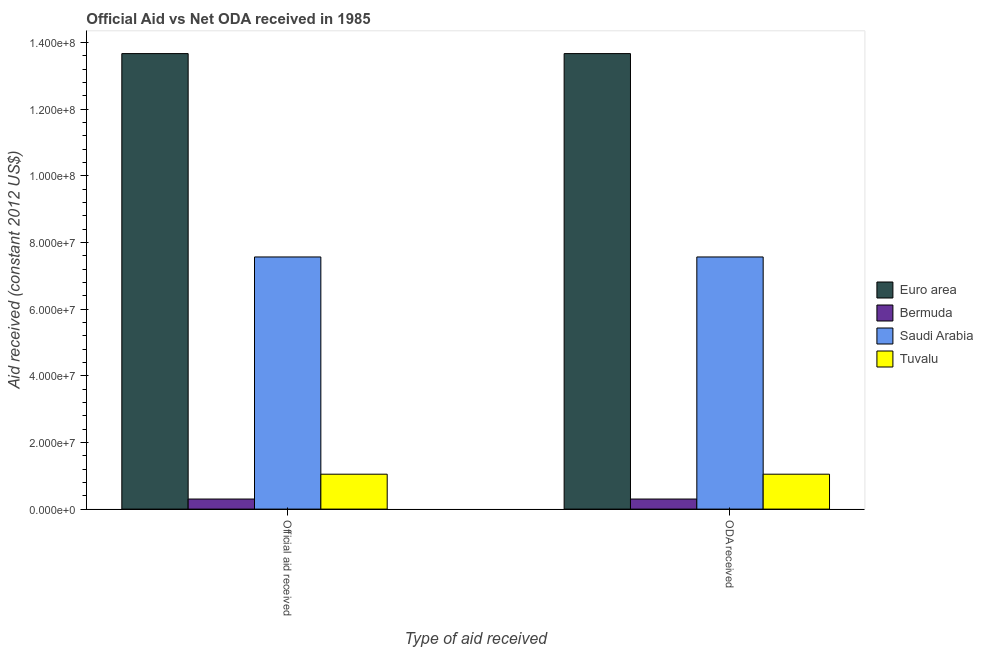How many different coloured bars are there?
Give a very brief answer. 4. How many bars are there on the 2nd tick from the left?
Offer a terse response. 4. What is the label of the 2nd group of bars from the left?
Provide a short and direct response. ODA received. What is the official aid received in Saudi Arabia?
Give a very brief answer. 7.56e+07. Across all countries, what is the maximum official aid received?
Offer a very short reply. 1.37e+08. Across all countries, what is the minimum oda received?
Offer a terse response. 3.02e+06. In which country was the official aid received maximum?
Provide a short and direct response. Euro area. In which country was the oda received minimum?
Make the answer very short. Bermuda. What is the total official aid received in the graph?
Keep it short and to the point. 2.26e+08. What is the difference between the official aid received in Saudi Arabia and that in Euro area?
Your answer should be very brief. -6.10e+07. What is the difference between the official aid received in Euro area and the oda received in Saudi Arabia?
Your answer should be very brief. 6.10e+07. What is the average oda received per country?
Your answer should be very brief. 5.64e+07. In how many countries, is the official aid received greater than 104000000 US$?
Offer a very short reply. 1. What is the ratio of the official aid received in Tuvalu to that in Euro area?
Provide a succinct answer. 0.08. Is the official aid received in Saudi Arabia less than that in Euro area?
Make the answer very short. Yes. In how many countries, is the oda received greater than the average oda received taken over all countries?
Provide a short and direct response. 2. What does the 2nd bar from the left in ODA received represents?
Ensure brevity in your answer.  Bermuda. What does the 3rd bar from the right in ODA received represents?
Provide a succinct answer. Bermuda. Are all the bars in the graph horizontal?
Your answer should be very brief. No. How many countries are there in the graph?
Give a very brief answer. 4. Are the values on the major ticks of Y-axis written in scientific E-notation?
Your answer should be compact. Yes. How many legend labels are there?
Provide a succinct answer. 4. How are the legend labels stacked?
Give a very brief answer. Vertical. What is the title of the graph?
Your answer should be compact. Official Aid vs Net ODA received in 1985 . Does "Seychelles" appear as one of the legend labels in the graph?
Ensure brevity in your answer.  No. What is the label or title of the X-axis?
Keep it short and to the point. Type of aid received. What is the label or title of the Y-axis?
Offer a terse response. Aid received (constant 2012 US$). What is the Aid received (constant 2012 US$) of Euro area in Official aid received?
Provide a short and direct response. 1.37e+08. What is the Aid received (constant 2012 US$) in Bermuda in Official aid received?
Give a very brief answer. 3.02e+06. What is the Aid received (constant 2012 US$) in Saudi Arabia in Official aid received?
Make the answer very short. 7.56e+07. What is the Aid received (constant 2012 US$) in Tuvalu in Official aid received?
Make the answer very short. 1.05e+07. What is the Aid received (constant 2012 US$) of Euro area in ODA received?
Make the answer very short. 1.37e+08. What is the Aid received (constant 2012 US$) of Bermuda in ODA received?
Your response must be concise. 3.02e+06. What is the Aid received (constant 2012 US$) of Saudi Arabia in ODA received?
Keep it short and to the point. 7.56e+07. What is the Aid received (constant 2012 US$) of Tuvalu in ODA received?
Keep it short and to the point. 1.05e+07. Across all Type of aid received, what is the maximum Aid received (constant 2012 US$) of Euro area?
Give a very brief answer. 1.37e+08. Across all Type of aid received, what is the maximum Aid received (constant 2012 US$) in Bermuda?
Your answer should be compact. 3.02e+06. Across all Type of aid received, what is the maximum Aid received (constant 2012 US$) in Saudi Arabia?
Give a very brief answer. 7.56e+07. Across all Type of aid received, what is the maximum Aid received (constant 2012 US$) in Tuvalu?
Offer a very short reply. 1.05e+07. Across all Type of aid received, what is the minimum Aid received (constant 2012 US$) of Euro area?
Your answer should be very brief. 1.37e+08. Across all Type of aid received, what is the minimum Aid received (constant 2012 US$) in Bermuda?
Provide a succinct answer. 3.02e+06. Across all Type of aid received, what is the minimum Aid received (constant 2012 US$) in Saudi Arabia?
Make the answer very short. 7.56e+07. Across all Type of aid received, what is the minimum Aid received (constant 2012 US$) of Tuvalu?
Ensure brevity in your answer.  1.05e+07. What is the total Aid received (constant 2012 US$) of Euro area in the graph?
Your answer should be compact. 2.73e+08. What is the total Aid received (constant 2012 US$) in Bermuda in the graph?
Make the answer very short. 6.04e+06. What is the total Aid received (constant 2012 US$) of Saudi Arabia in the graph?
Provide a succinct answer. 1.51e+08. What is the total Aid received (constant 2012 US$) of Tuvalu in the graph?
Keep it short and to the point. 2.09e+07. What is the difference between the Aid received (constant 2012 US$) of Euro area in Official aid received and that in ODA received?
Your answer should be compact. 0. What is the difference between the Aid received (constant 2012 US$) in Bermuda in Official aid received and that in ODA received?
Provide a short and direct response. 0. What is the difference between the Aid received (constant 2012 US$) of Tuvalu in Official aid received and that in ODA received?
Provide a succinct answer. 0. What is the difference between the Aid received (constant 2012 US$) of Euro area in Official aid received and the Aid received (constant 2012 US$) of Bermuda in ODA received?
Provide a short and direct response. 1.34e+08. What is the difference between the Aid received (constant 2012 US$) in Euro area in Official aid received and the Aid received (constant 2012 US$) in Saudi Arabia in ODA received?
Keep it short and to the point. 6.10e+07. What is the difference between the Aid received (constant 2012 US$) of Euro area in Official aid received and the Aid received (constant 2012 US$) of Tuvalu in ODA received?
Offer a very short reply. 1.26e+08. What is the difference between the Aid received (constant 2012 US$) of Bermuda in Official aid received and the Aid received (constant 2012 US$) of Saudi Arabia in ODA received?
Provide a succinct answer. -7.26e+07. What is the difference between the Aid received (constant 2012 US$) in Bermuda in Official aid received and the Aid received (constant 2012 US$) in Tuvalu in ODA received?
Give a very brief answer. -7.45e+06. What is the difference between the Aid received (constant 2012 US$) in Saudi Arabia in Official aid received and the Aid received (constant 2012 US$) in Tuvalu in ODA received?
Your answer should be very brief. 6.52e+07. What is the average Aid received (constant 2012 US$) in Euro area per Type of aid received?
Offer a very short reply. 1.37e+08. What is the average Aid received (constant 2012 US$) of Bermuda per Type of aid received?
Offer a very short reply. 3.02e+06. What is the average Aid received (constant 2012 US$) in Saudi Arabia per Type of aid received?
Make the answer very short. 7.56e+07. What is the average Aid received (constant 2012 US$) of Tuvalu per Type of aid received?
Your answer should be compact. 1.05e+07. What is the difference between the Aid received (constant 2012 US$) in Euro area and Aid received (constant 2012 US$) in Bermuda in Official aid received?
Offer a very short reply. 1.34e+08. What is the difference between the Aid received (constant 2012 US$) of Euro area and Aid received (constant 2012 US$) of Saudi Arabia in Official aid received?
Make the answer very short. 6.10e+07. What is the difference between the Aid received (constant 2012 US$) in Euro area and Aid received (constant 2012 US$) in Tuvalu in Official aid received?
Make the answer very short. 1.26e+08. What is the difference between the Aid received (constant 2012 US$) in Bermuda and Aid received (constant 2012 US$) in Saudi Arabia in Official aid received?
Offer a very short reply. -7.26e+07. What is the difference between the Aid received (constant 2012 US$) in Bermuda and Aid received (constant 2012 US$) in Tuvalu in Official aid received?
Keep it short and to the point. -7.45e+06. What is the difference between the Aid received (constant 2012 US$) of Saudi Arabia and Aid received (constant 2012 US$) of Tuvalu in Official aid received?
Provide a short and direct response. 6.52e+07. What is the difference between the Aid received (constant 2012 US$) of Euro area and Aid received (constant 2012 US$) of Bermuda in ODA received?
Your response must be concise. 1.34e+08. What is the difference between the Aid received (constant 2012 US$) of Euro area and Aid received (constant 2012 US$) of Saudi Arabia in ODA received?
Your response must be concise. 6.10e+07. What is the difference between the Aid received (constant 2012 US$) in Euro area and Aid received (constant 2012 US$) in Tuvalu in ODA received?
Your answer should be very brief. 1.26e+08. What is the difference between the Aid received (constant 2012 US$) in Bermuda and Aid received (constant 2012 US$) in Saudi Arabia in ODA received?
Keep it short and to the point. -7.26e+07. What is the difference between the Aid received (constant 2012 US$) in Bermuda and Aid received (constant 2012 US$) in Tuvalu in ODA received?
Provide a short and direct response. -7.45e+06. What is the difference between the Aid received (constant 2012 US$) of Saudi Arabia and Aid received (constant 2012 US$) of Tuvalu in ODA received?
Provide a succinct answer. 6.52e+07. What is the ratio of the Aid received (constant 2012 US$) of Euro area in Official aid received to that in ODA received?
Your answer should be compact. 1. What is the ratio of the Aid received (constant 2012 US$) in Bermuda in Official aid received to that in ODA received?
Ensure brevity in your answer.  1. What is the difference between the highest and the second highest Aid received (constant 2012 US$) of Euro area?
Provide a succinct answer. 0. What is the difference between the highest and the second highest Aid received (constant 2012 US$) of Bermuda?
Offer a terse response. 0. What is the difference between the highest and the second highest Aid received (constant 2012 US$) in Saudi Arabia?
Offer a terse response. 0. What is the difference between the highest and the lowest Aid received (constant 2012 US$) of Saudi Arabia?
Your answer should be compact. 0. 